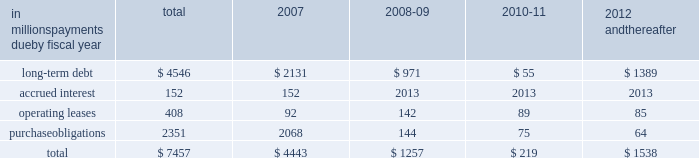Guarantees to third parties .
We have , however , issued guar- antees and comfort letters of $ 171 million for the debt and other obligations of unconsolidated affiliates , primarily for cpw .
In addition , off-balance sheet arrangements are gener- ally limited to the future payments under noncancelable operating leases , which totaled $ 408 million at may 28 , at may 28 , 2006 , we had invested in four variable interest entities ( vies ) .
We are the primary beneficiary ( pb ) of general mills capital , inc .
( gm capital ) , a subsidiary that we consolidate as set forth in note eight to the consoli- dated financial statements appearing on pages 43 and 44 in item eight of this report .
We also have an interest in a contract manufacturer at our former facility in geneva , illi- nois .
Even though we are the pb , we have not consolidated this entity because it is not material to our results of oper- ations , financial condition , or liquidity at may 28 , 2006 .
This entity had property and equipment of $ 50 million and long-term debt of $ 50 million at may 28 , 2006 .
We are not the pb of the remaining two vies .
Our maximum exposure to loss from these vies is limited to the $ 150 million minority interest in gm capital , the contract manufactur- er 2019s debt and our $ 6 million of equity investments in the two remaining vies .
The table summarizes our future estimated cash payments under existing contractual obligations , including payments due by period .
The majority of the purchase obligations represent commitments for raw mate- rial and packaging to be utilized in the normal course of business and for consumer-directed marketing commit- ments that support our brands .
The net fair value of our interest rate and equity swaps was $ 159 million at may 28 , 2006 , based on market values as of that date .
Future changes in market values will impact the amount of cash ultimately paid or received to settle those instruments in the future .
Other long-term obligations primarily consist of income taxes , accrued compensation and benefits , and miscella- neous liabilities .
We are unable to estimate the timing of the payments for these items .
We do not have significant statutory or contractual funding requirements for our defined-benefit retirement and other postretirement benefit plans .
Further information on these plans , including our expected contributions for fiscal 2007 , is set forth in note thirteen to the consolidated financial statements appearing on pages 47 through 50 in item eight of this report .
In millions , payments due by fiscal year total 2007 2008-09 2010-11 2012 and thereafter .
Significant accounting estimates for a complete description of our significant accounting policies , please see note one to the consolidated financial statements appearing on pages 35 through 37 in item eight of this report .
Our significant accounting estimates are those that have meaningful impact on the reporting of our financial condition and results of operations .
These poli- cies include our accounting for trade and consumer promotion activities ; goodwill and other intangible asset impairments ; income taxes ; and pension and other postretirement benefits .
Trade and consumer promotion activities we report sales net of certain coupon and trade promotion costs .
The consumer coupon costs recorded as a reduction of sales are based on the estimated redemption value of those coupons , as determined by historical patterns of coupon redemption and consideration of current market conditions such as competitive activity in those product categories .
The trade promotion costs include payments to customers to perform merchandising activities on our behalf , such as advertising or in-store displays , discounts to our list prices to lower retail shelf prices , and payments to gain distribution of new products .
The cost of these activi- ties is recognized as the related revenue is recorded , which generally precedes the actual cash expenditure .
The recog- nition of these costs requires estimation of customer participation and performance levels .
These estimates are made based on the quantity of customer sales , the timing and forecasted costs of promotional activities , and other factors .
Differences between estimated expenses and actual costs are normally insignificant and are recognized as a change in management estimate in a subsequent period .
Our accrued trade and consumer promotion liability was $ 339 million as of may 28 , 2006 , and $ 283 million as of may 29 , 2005 .
Our unit volume in the last week of each quarter is consis- tently higher than the average for the preceding weeks of the quarter .
In comparison to the average daily shipments in the first 12 weeks of a quarter , the final week of each quarter has approximately two to four days 2019 worth of incre- mental shipments ( based on a five-day week ) , reflecting increased promotional activity at the end of the quarter .
This increased activity includes promotions to assure that our customers have sufficient inventory on hand to support major marketing events or increased seasonal demand early in the next quarter , as well as promotions intended to help achieve interim unit volume targets .
If , due to quarter-end promotions or other reasons , our customers purchase more product in any reporting period than end-consumer demand will require in future periods , our sales level in future reporting periods could be adversely affected. .
What portion of the total obligations due by fiscal year 2007 are dedicated for repayment of long-term debt? 
Computations: (2131 / 4443)
Answer: 0.47963. 